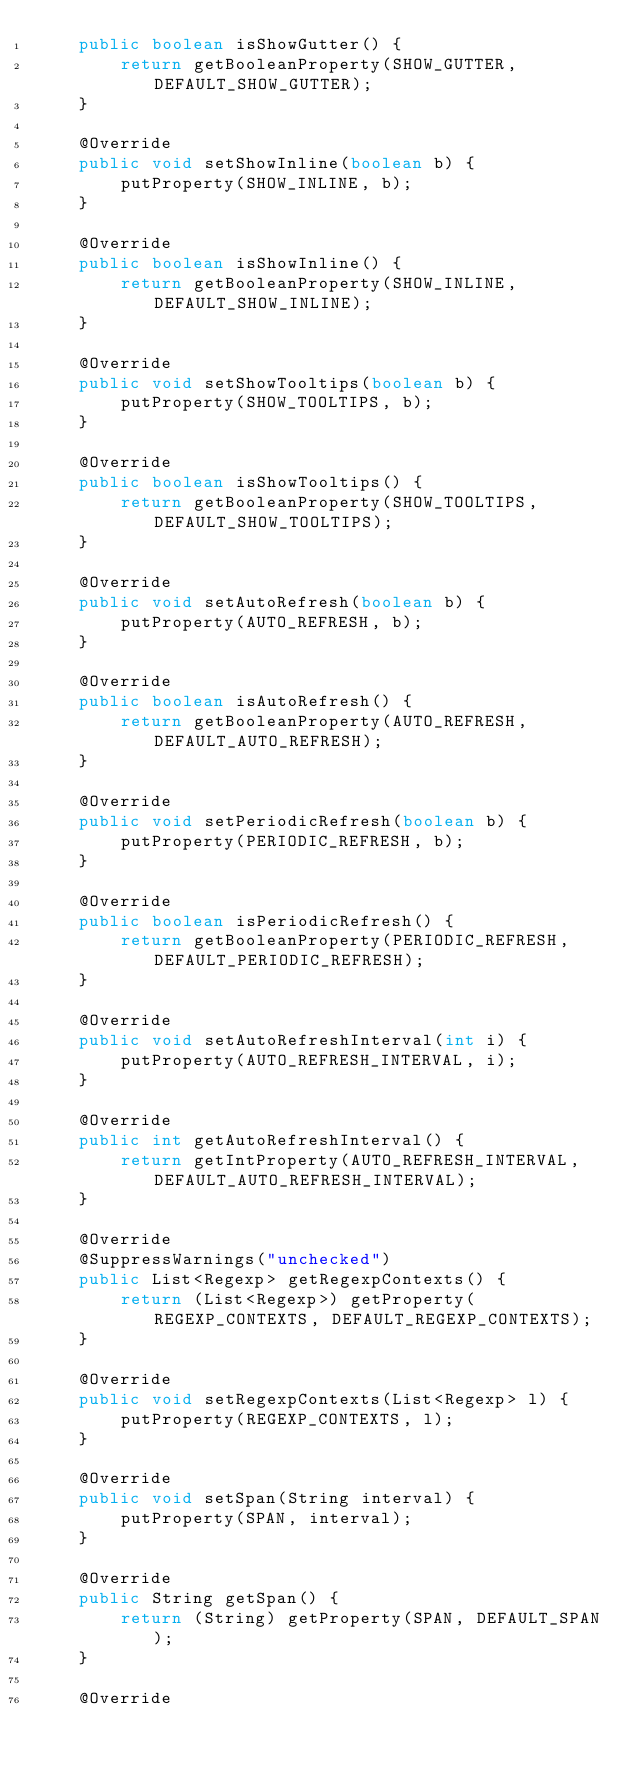Convert code to text. <code><loc_0><loc_0><loc_500><loc_500><_Java_>    public boolean isShowGutter() {
        return getBooleanProperty(SHOW_GUTTER, DEFAULT_SHOW_GUTTER);
    }

    @Override
    public void setShowInline(boolean b) {
        putProperty(SHOW_INLINE, b);
    }

    @Override
    public boolean isShowInline() {
        return getBooleanProperty(SHOW_INLINE, DEFAULT_SHOW_INLINE);
    }

    @Override
    public void setShowTooltips(boolean b) {
        putProperty(SHOW_TOOLTIPS, b);
    }

    @Override
    public boolean isShowTooltips() {
        return getBooleanProperty(SHOW_TOOLTIPS, DEFAULT_SHOW_TOOLTIPS);
    }

    @Override
    public void setAutoRefresh(boolean b) {
        putProperty(AUTO_REFRESH, b);
    }

    @Override
    public boolean isAutoRefresh() {
        return getBooleanProperty(AUTO_REFRESH, DEFAULT_AUTO_REFRESH);
    }

    @Override
    public void setPeriodicRefresh(boolean b) {
        putProperty(PERIODIC_REFRESH, b);
    }

    @Override
    public boolean isPeriodicRefresh() {
        return getBooleanProperty(PERIODIC_REFRESH, DEFAULT_PERIODIC_REFRESH);
    }

    @Override
    public void setAutoRefreshInterval(int i) {
        putProperty(AUTO_REFRESH_INTERVAL, i);
    }

    @Override
    public int getAutoRefreshInterval() {
        return getIntProperty(AUTO_REFRESH_INTERVAL, DEFAULT_AUTO_REFRESH_INTERVAL);
    }

    @Override
    @SuppressWarnings("unchecked")
    public List<Regexp> getRegexpContexts() {
        return (List<Regexp>) getProperty(REGEXP_CONTEXTS, DEFAULT_REGEXP_CONTEXTS);
    }

    @Override
    public void setRegexpContexts(List<Regexp> l) {
        putProperty(REGEXP_CONTEXTS, l);
    }

    @Override
    public void setSpan(String interval) {
        putProperty(SPAN, interval);
    }

    @Override
    public String getSpan() {
        return (String) getProperty(SPAN, DEFAULT_SPAN);
    }

    @Override</code> 